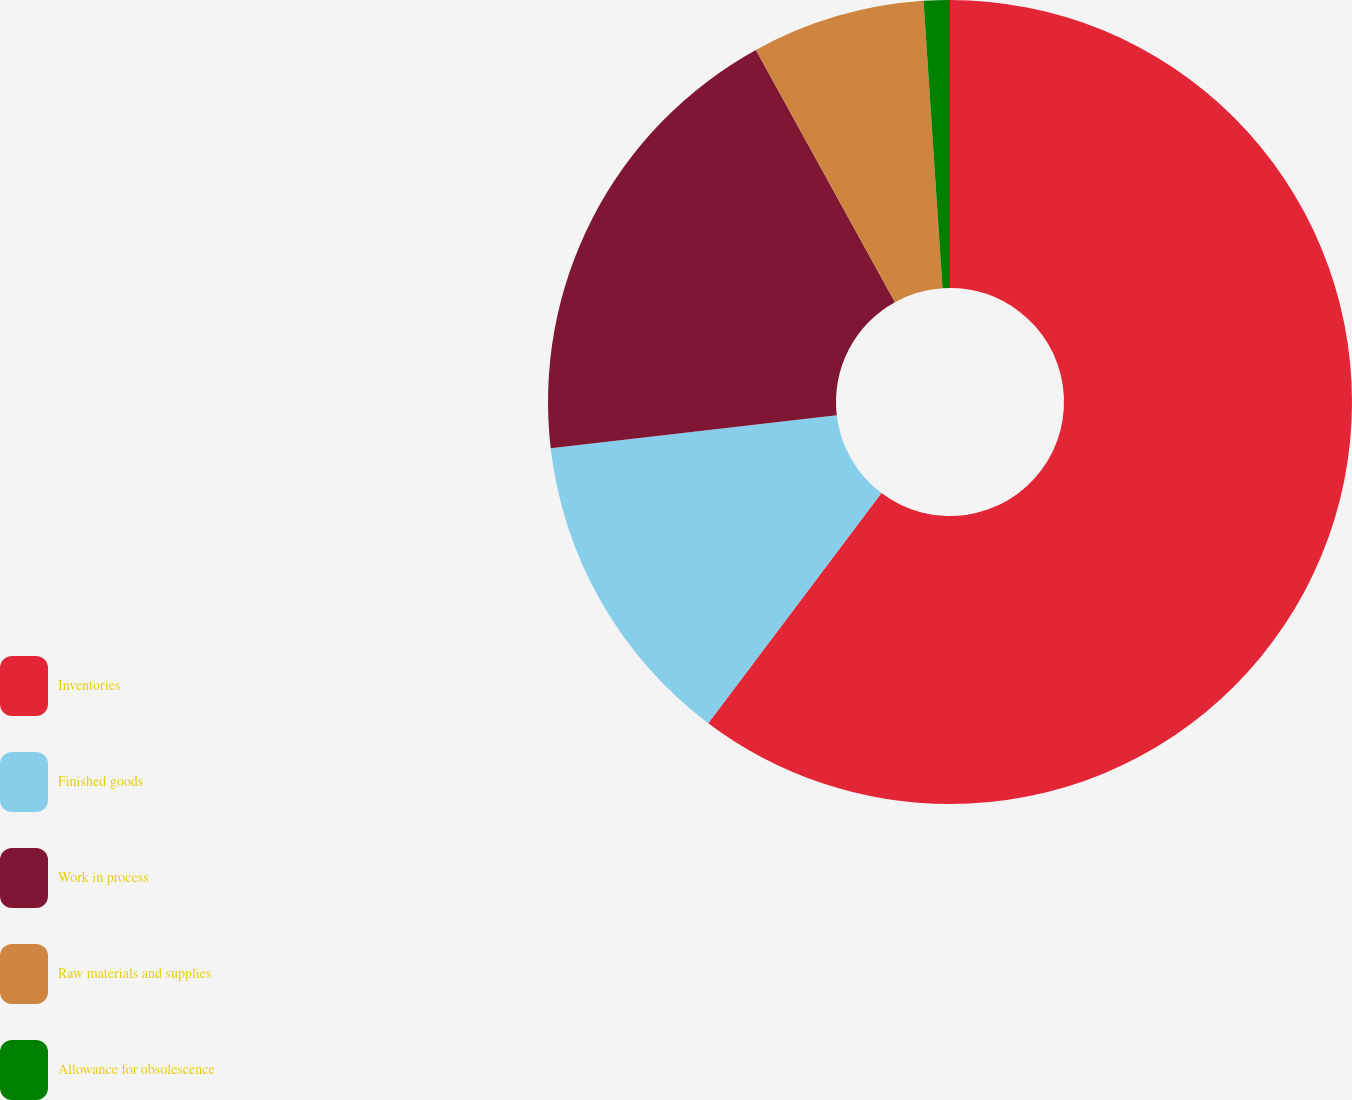<chart> <loc_0><loc_0><loc_500><loc_500><pie_chart><fcel>Inventories<fcel>Finished goods<fcel>Work in process<fcel>Raw materials and supplies<fcel>Allowance for obsolescence<nl><fcel>60.27%<fcel>12.89%<fcel>18.82%<fcel>6.97%<fcel>1.05%<nl></chart> 